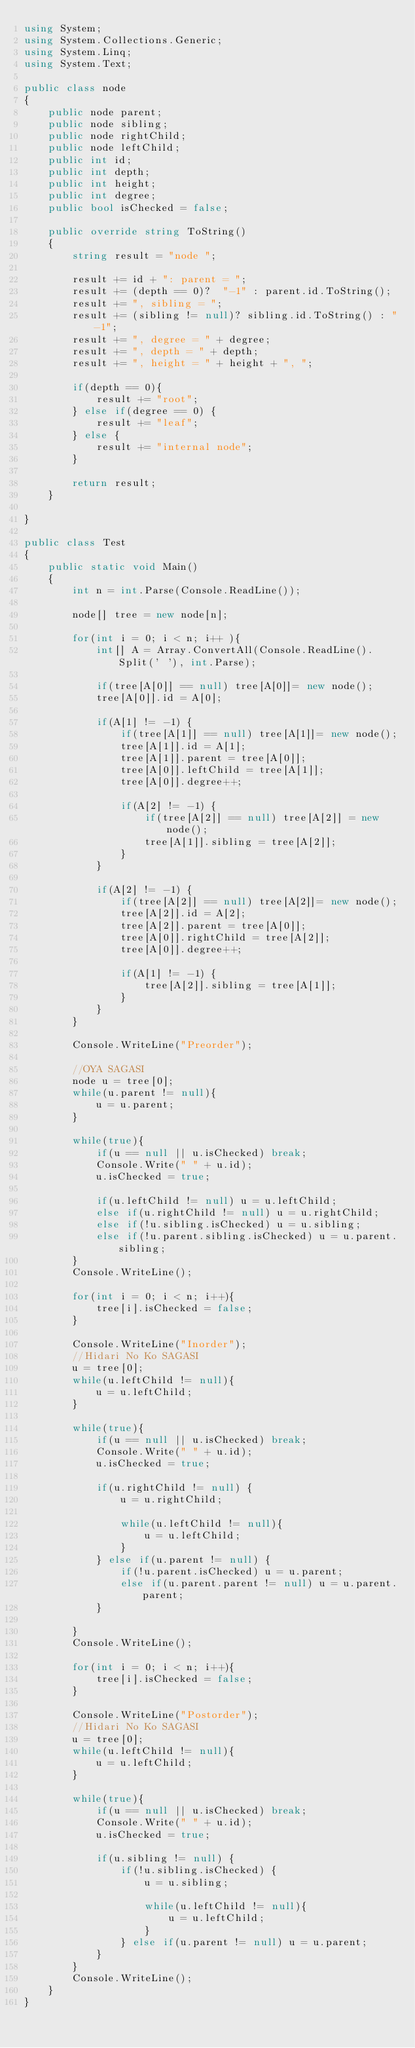Convert code to text. <code><loc_0><loc_0><loc_500><loc_500><_C#_>using System;
using System.Collections.Generic;
using System.Linq;
using System.Text;

public class node
{
	public node parent;
	public node sibling;
	public node rightChild;
	public node leftChild;
	public int id;
	public int depth;
	public int height;
	public int degree;
	public bool isChecked = false;
	
	public override string ToString()
	{
		string result = "node ";
		
		result += id + ": parent = ";
		result += (depth == 0)?  "-1" : parent.id.ToString();
		result += ", sibling = ";
		result += (sibling != null)? sibling.id.ToString() : "-1";
		result += ", degree = " + degree;
		result += ", depth = " + depth;
		result += ", height = " + height + ", ";
		
		if(depth == 0){
			result += "root";
		} else if(degree == 0) {
			result += "leaf";
		} else {
			result += "internal node";
		}
		
		return result;
	}
	
}

public class Test
{
	public static void Main()
	{
		int n = int.Parse(Console.ReadLine());
		
		node[] tree = new node[n];
		
		for(int i = 0; i < n; i++ ){
			int[] A = Array.ConvertAll(Console.ReadLine().Split(' '), int.Parse);
			
			if(tree[A[0]] == null) tree[A[0]]= new node();
			tree[A[0]].id = A[0];
			
			if(A[1] != -1) {
				if(tree[A[1]] == null) tree[A[1]]= new node();
				tree[A[1]].id = A[1];
				tree[A[1]].parent = tree[A[0]];
				tree[A[0]].leftChild = tree[A[1]];
				tree[A[0]].degree++;
				
				if(A[2] != -1) {
					if(tree[A[2]] == null) tree[A[2]] = new node();
					tree[A[1]].sibling = tree[A[2]];
				}
			}
			
			if(A[2] != -1) {
				if(tree[A[2]] == null) tree[A[2]]= new node();
				tree[A[2]].id = A[2];
				tree[A[2]].parent = tree[A[0]];
				tree[A[0]].rightChild = tree[A[2]];
				tree[A[0]].degree++;
				
				if(A[1] != -1) {
					tree[A[2]].sibling = tree[A[1]];
				}
			}
		}
        
        Console.WriteLine("Preorder");
        
        //OYA SAGASI
        node u = tree[0];
		while(u.parent != null){
			u = u.parent;
		}
		
		while(true){
			if(u == null || u.isChecked) break;
			Console.Write(" " + u.id);
			u.isChecked = true;
			
			if(u.leftChild != null) u = u.leftChild;
			else if(u.rightChild != null) u = u.rightChild;
			else if(!u.sibling.isChecked) u = u.sibling;
			else if(!u.parent.sibling.isChecked) u = u.parent.sibling;
		}
		Console.WriteLine();
		
		for(int i = 0; i < n; i++){
			tree[i].isChecked = false;
		}
		
		Console.WriteLine("Inorder");
		//Hidari No Ko SAGASI
        u = tree[0];
		while(u.leftChild != null){
			u = u.leftChild;
		}
		
		while(true){
			if(u == null || u.isChecked) break;
			Console.Write(" " + u.id);
			u.isChecked = true;
			
			if(u.rightChild != null) {
				u = u.rightChild;
				
				while(u.leftChild != null){
					u = u.leftChild;
				}
			} else if(u.parent != null) {
				if(!u.parent.isChecked) u = u.parent;
				else if(u.parent.parent != null) u = u.parent.parent;
			}
			
		}
		Console.WriteLine();
		
		for(int i = 0; i < n; i++){
			tree[i].isChecked = false;
		}
		
		Console.WriteLine("Postorder");
		//Hidari No Ko SAGASI
        u = tree[0];
		while(u.leftChild != null){
			u = u.leftChild;
		}
		
		while(true){
			if(u == null || u.isChecked) break;
			Console.Write(" " + u.id);
			u.isChecked = true;
			
			if(u.sibling != null) {
				if(!u.sibling.isChecked) { 
					u = u.sibling;
					
					while(u.leftChild != null){
						u = u.leftChild;
					}
				} else if(u.parent != null) u = u.parent;
			}
		}
		Console.WriteLine();
	}
}</code> 